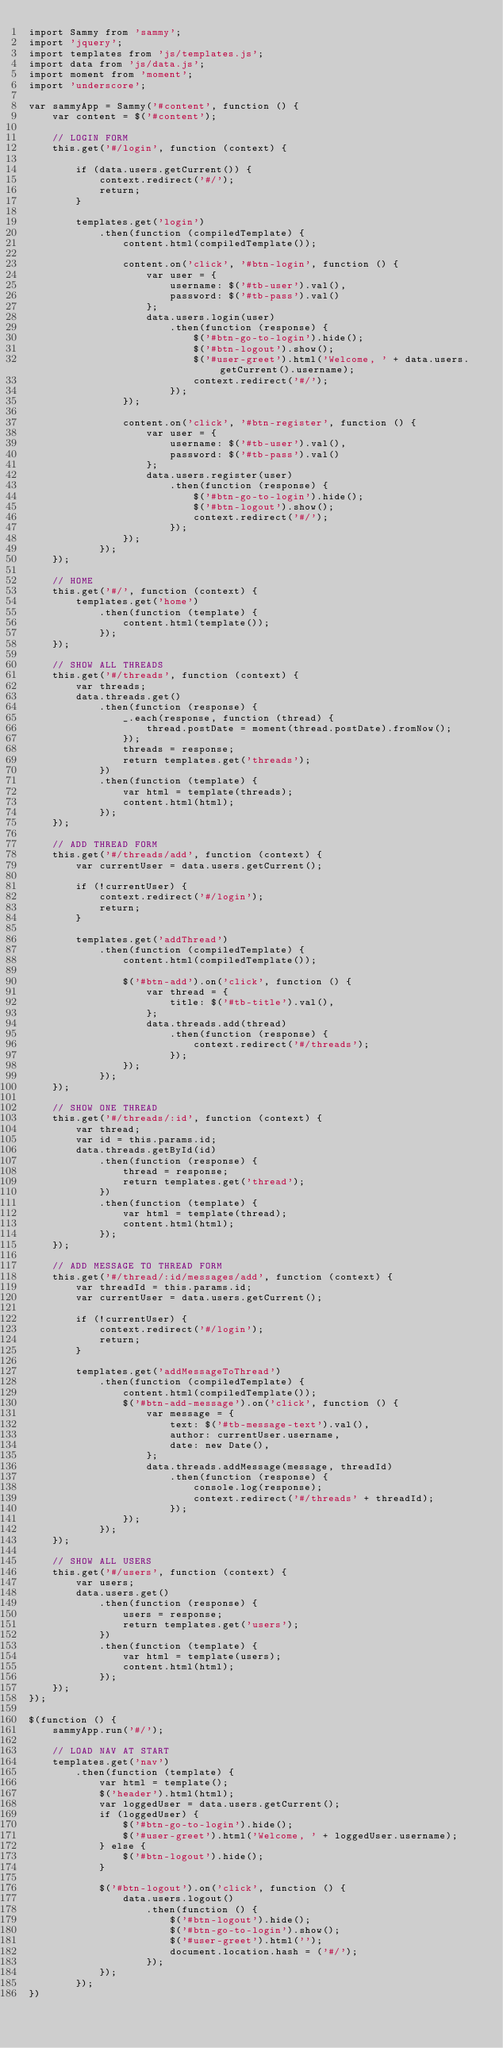<code> <loc_0><loc_0><loc_500><loc_500><_JavaScript_>import Sammy from 'sammy';
import 'jquery';
import templates from 'js/templates.js';
import data from 'js/data.js';
import moment from 'moment';
import 'underscore';

var sammyApp = Sammy('#content', function () {
    var content = $('#content');

    // LOGIN FORM
    this.get('#/login', function (context) {

        if (data.users.getCurrent()) {
            context.redirect('#/');
            return;
        }

        templates.get('login')
            .then(function (compiledTemplate) {
                content.html(compiledTemplate());

                content.on('click', '#btn-login', function () {
                    var user = {
                        username: $('#tb-user').val(),
                        password: $('#tb-pass').val()
                    };
                    data.users.login(user)
                        .then(function (response) {
                            $('#btn-go-to-login').hide();
                            $('#btn-logout').show();
                            $('#user-greet').html('Welcome, ' + data.users.getCurrent().username);
                            context.redirect('#/');
                        });
                });

                content.on('click', '#btn-register', function () {
                    var user = {
                        username: $('#tb-user').val(),
                        password: $('#tb-pass').val()
                    };
                    data.users.register(user)
                        .then(function (response) {
                            $('#btn-go-to-login').hide();
                            $('#btn-logout').show();
                            context.redirect('#/');
                        });
                });
            });
    });
    
    // HOME
    this.get('#/', function (context) {
        templates.get('home')
            .then(function (template) {
                content.html(template());
            });
    });

    // SHOW ALL THREADS
    this.get('#/threads', function (context) {
        var threads;
        data.threads.get()
            .then(function (response) {
                _.each(response, function (thread) {
                    thread.postDate = moment(thread.postDate).fromNow();
                });
                threads = response;
                return templates.get('threads');
            })
            .then(function (template) {
                var html = template(threads);
                content.html(html);
            });
    });

    // ADD THREAD FORM
    this.get('#/threads/add', function (context) {
        var currentUser = data.users.getCurrent();

        if (!currentUser) {
            context.redirect('#/login');
            return;
        }

        templates.get('addThread')
            .then(function (compiledTemplate) {
                content.html(compiledTemplate());

                $('#btn-add').on('click', function () {
                    var thread = {
                        title: $('#tb-title').val(),
                    };
                    data.threads.add(thread)
                        .then(function (response) {
                            context.redirect('#/threads');
                        });
                });
            });
    });

    // SHOW ONE THREAD
    this.get('#/threads/:id', function (context) {
        var thread;
        var id = this.params.id;
        data.threads.getById(id)
            .then(function (response) {
                thread = response;
                return templates.get('thread');
            })
            .then(function (template) {
                var html = template(thread);
                content.html(html);
            });
    });

    // ADD MESSAGE TO THREAD FORM
    this.get('#/thread/:id/messages/add', function (context) {
        var threadId = this.params.id;
        var currentUser = data.users.getCurrent();

        if (!currentUser) {
            context.redirect('#/login');
            return;
        }

        templates.get('addMessageToThread')
            .then(function (compiledTemplate) {
                content.html(compiledTemplate());
                $('#btn-add-message').on('click', function () {
                    var message = {
                        text: $('#tb-message-text').val(),
                        author: currentUser.username,
                        date: new Date(),
                    };
                    data.threads.addMessage(message, threadId)
                        .then(function (response) {
                            console.log(response);
                            context.redirect('#/threads' + threadId);
                        });
                });
            });
    });

    // SHOW ALL USERS
    this.get('#/users', function (context) {
        var users;
        data.users.get()
            .then(function (response) {
                users = response;
                return templates.get('users');
            })
            .then(function (template) {
                var html = template(users);
                content.html(html);
            });
    });
});

$(function () {
    sammyApp.run('#/');
    
    // LOAD NAV AT START
    templates.get('nav')
        .then(function (template) {
            var html = template();
            $('header').html(html);
            var loggedUser = data.users.getCurrent();
            if (loggedUser) {
                $('#btn-go-to-login').hide();
                $('#user-greet').html('Welcome, ' + loggedUser.username);
            } else {
                $('#btn-logout').hide();
            }

            $('#btn-logout').on('click', function () {
                data.users.logout()
                    .then(function () {
                        $('#btn-logout').hide();
                        $('#btn-go-to-login').show();
                        $('#user-greet').html('');
                        document.location.hash = ('#/');
                    });
            });
        });
})
</code> 